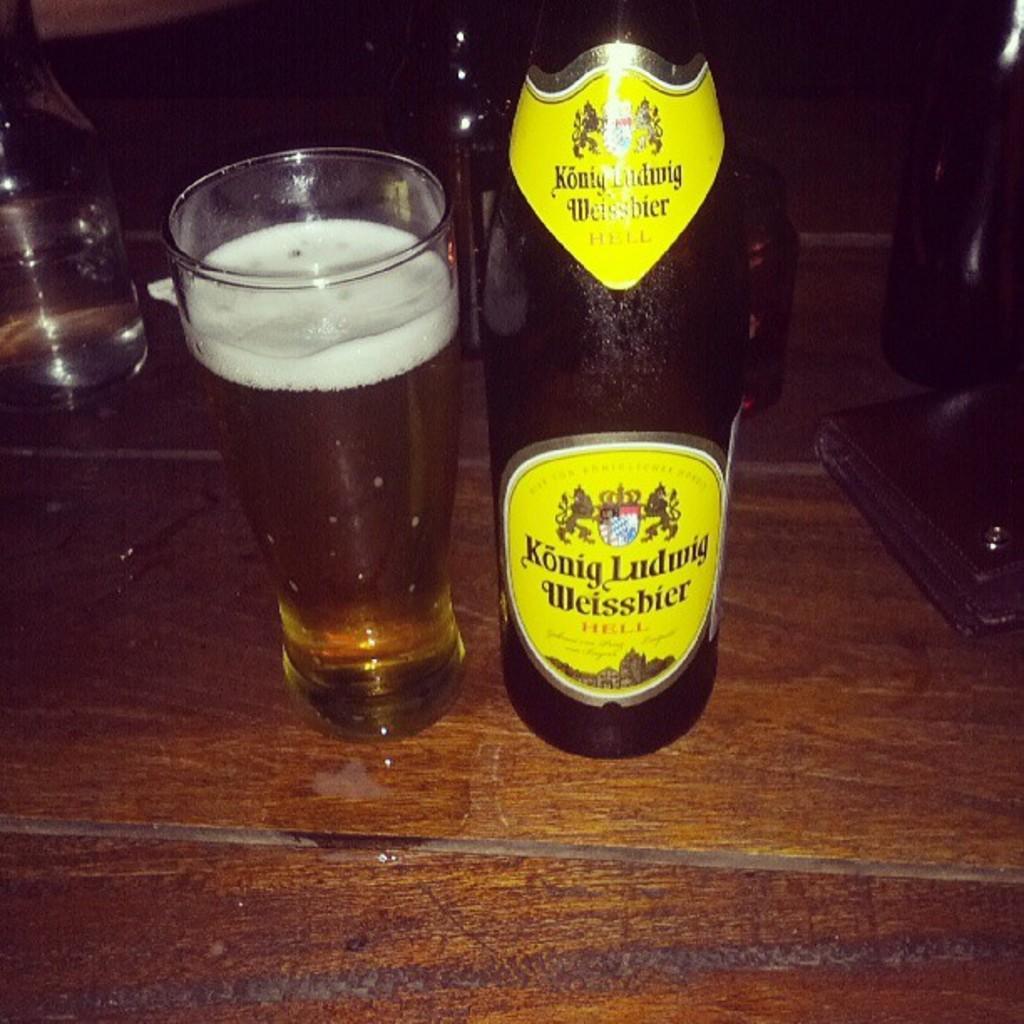In one or two sentences, can you explain what this image depicts? In the middle of the image, there is a glass filled with drink on the wooden table. Beside this glass, there is a bottle. In the background, there are bottles. And the background is dark in color. 